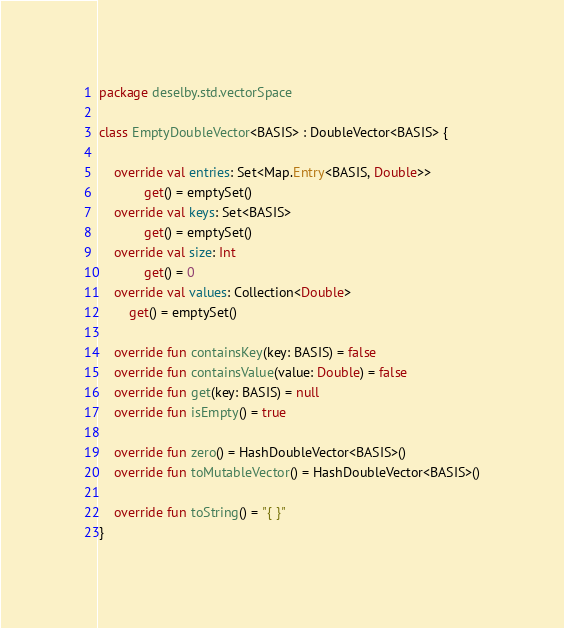<code> <loc_0><loc_0><loc_500><loc_500><_Kotlin_>package deselby.std.vectorSpace

class EmptyDoubleVector<BASIS> : DoubleVector<BASIS> {

    override val entries: Set<Map.Entry<BASIS, Double>>
            get() = emptySet()
    override val keys: Set<BASIS>
            get() = emptySet()
    override val size: Int
            get() = 0
    override val values: Collection<Double>
        get() = emptySet()

    override fun containsKey(key: BASIS) = false
    override fun containsValue(value: Double) = false
    override fun get(key: BASIS) = null
    override fun isEmpty() = true

    override fun zero() = HashDoubleVector<BASIS>()
    override fun toMutableVector() = HashDoubleVector<BASIS>()

    override fun toString() = "{ }"
}</code> 